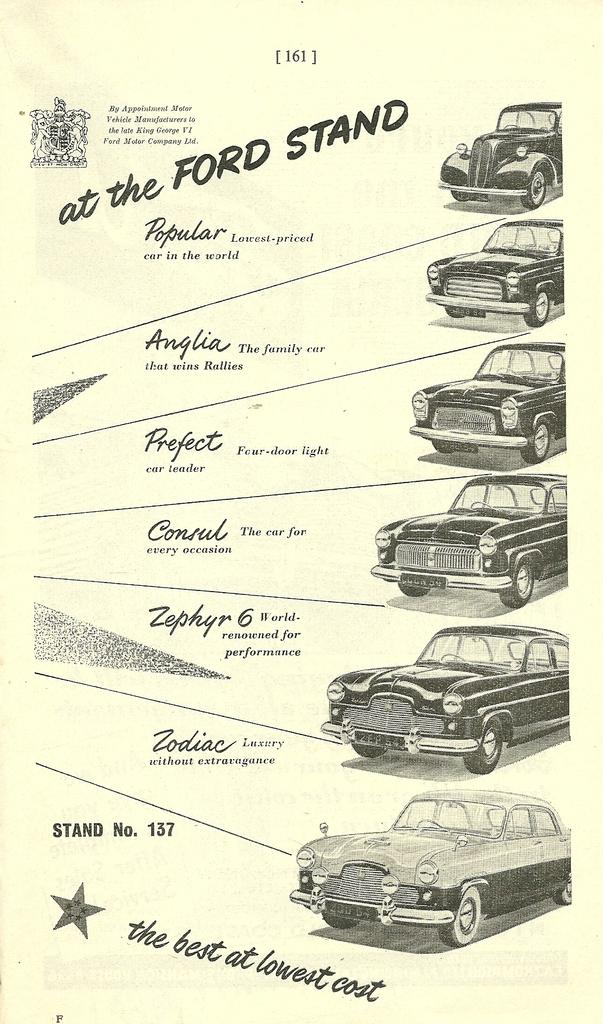What type of vehicles are depicted in the picture? There are images of cars in the picture. What color are the cars? The cars are black in color. Is there any text or writing associated with the cars in the picture? Yes, there is something written beside the cars. Can you see a person walking beside the cars at night in the image? There is no person or nighttime setting depicted in the image; it only shows images of black cars with something written beside them. 